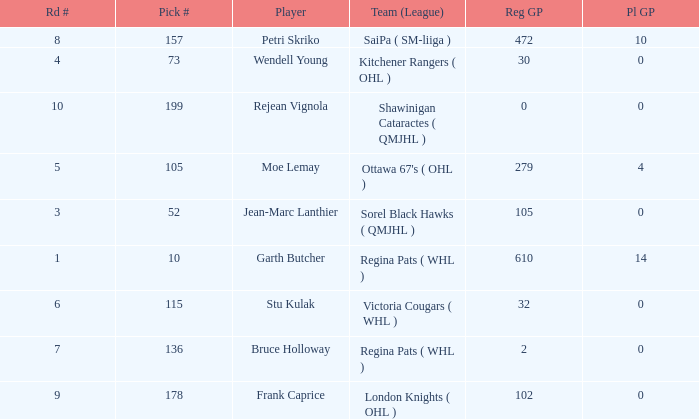What is the mean road number when Moe Lemay is the player? 5.0. 